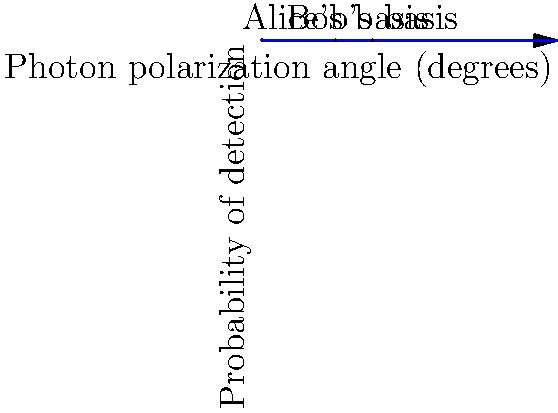In a quantum key distribution system using the BB84 protocol, Alice sends a photon polarized at 90° and Bob measures it using a basis rotated 45° from Alice's. What is the probability that Bob correctly detects the photon's polarization? To solve this problem, we need to follow these steps:

1. Understand the BB84 protocol:
   - Alice sends photons polarized in one of four states: 0°, 45°, 90°, or 135°.
   - Bob measures each photon using either a rectilinear (0°/90°) or diagonal (45°/135°) basis.

2. Identify the given information:
   - Alice's photon is polarized at 90°.
   - Bob's measurement basis is rotated 45° from Alice's, so it's at 135°.

3. Calculate the probability using quantum mechanics:
   - The probability of detecting a photon in a given basis is given by Malus's law:
     $$P = \cos^2(\theta)$$
   where $\theta$ is the angle between the photon's polarization and the measurement basis.

4. Determine the angle between Alice's polarization and Bob's basis:
   $$\theta = 135° - 90° = 45°$$

5. Apply Malus's law:
   $$P = \cos^2(45°) = (\frac{1}{\sqrt{2}})^2 = \frac{1}{2} = 0.5$$

Therefore, the probability that Bob correctly detects the photon's polarization is 0.5 or 50%.
Answer: 0.5 